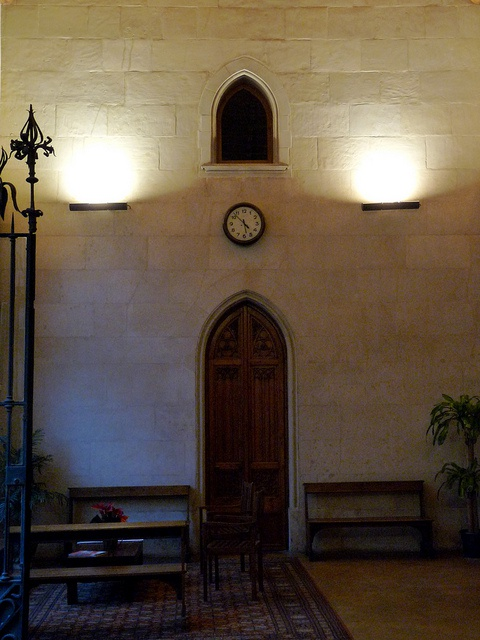Describe the objects in this image and their specific colors. I can see bench in tan and black tones, potted plant in tan, black, and darkgreen tones, potted plant in tan, black, navy, and darkblue tones, bench in tan and black tones, and clock in tan, black, olive, and gray tones in this image. 